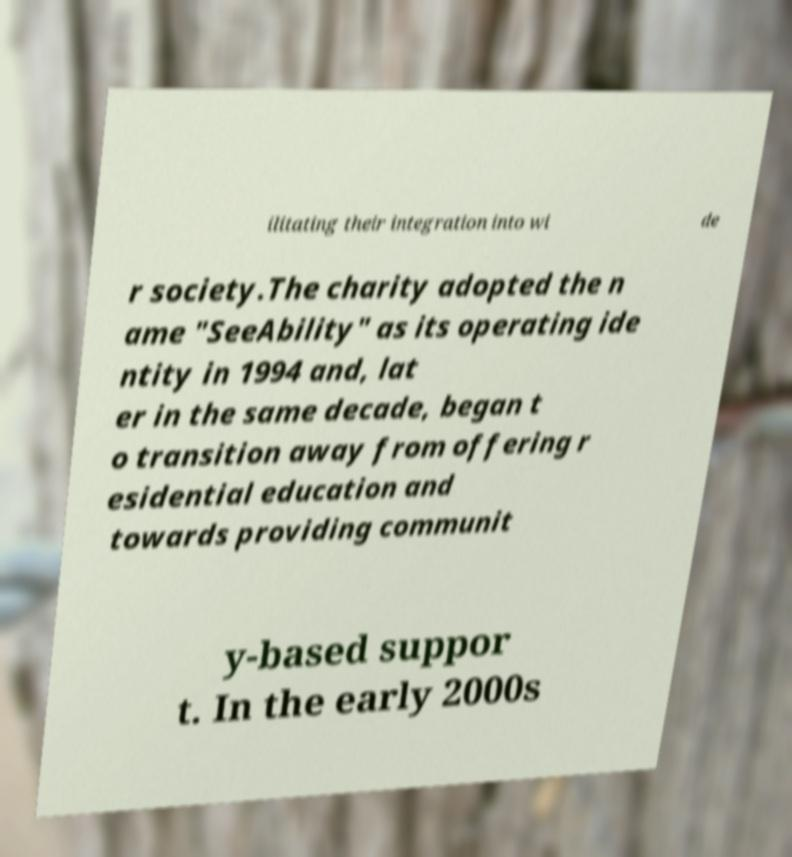Please identify and transcribe the text found in this image. ilitating their integration into wi de r society.The charity adopted the n ame "SeeAbility" as its operating ide ntity in 1994 and, lat er in the same decade, began t o transition away from offering r esidential education and towards providing communit y-based suppor t. In the early 2000s 